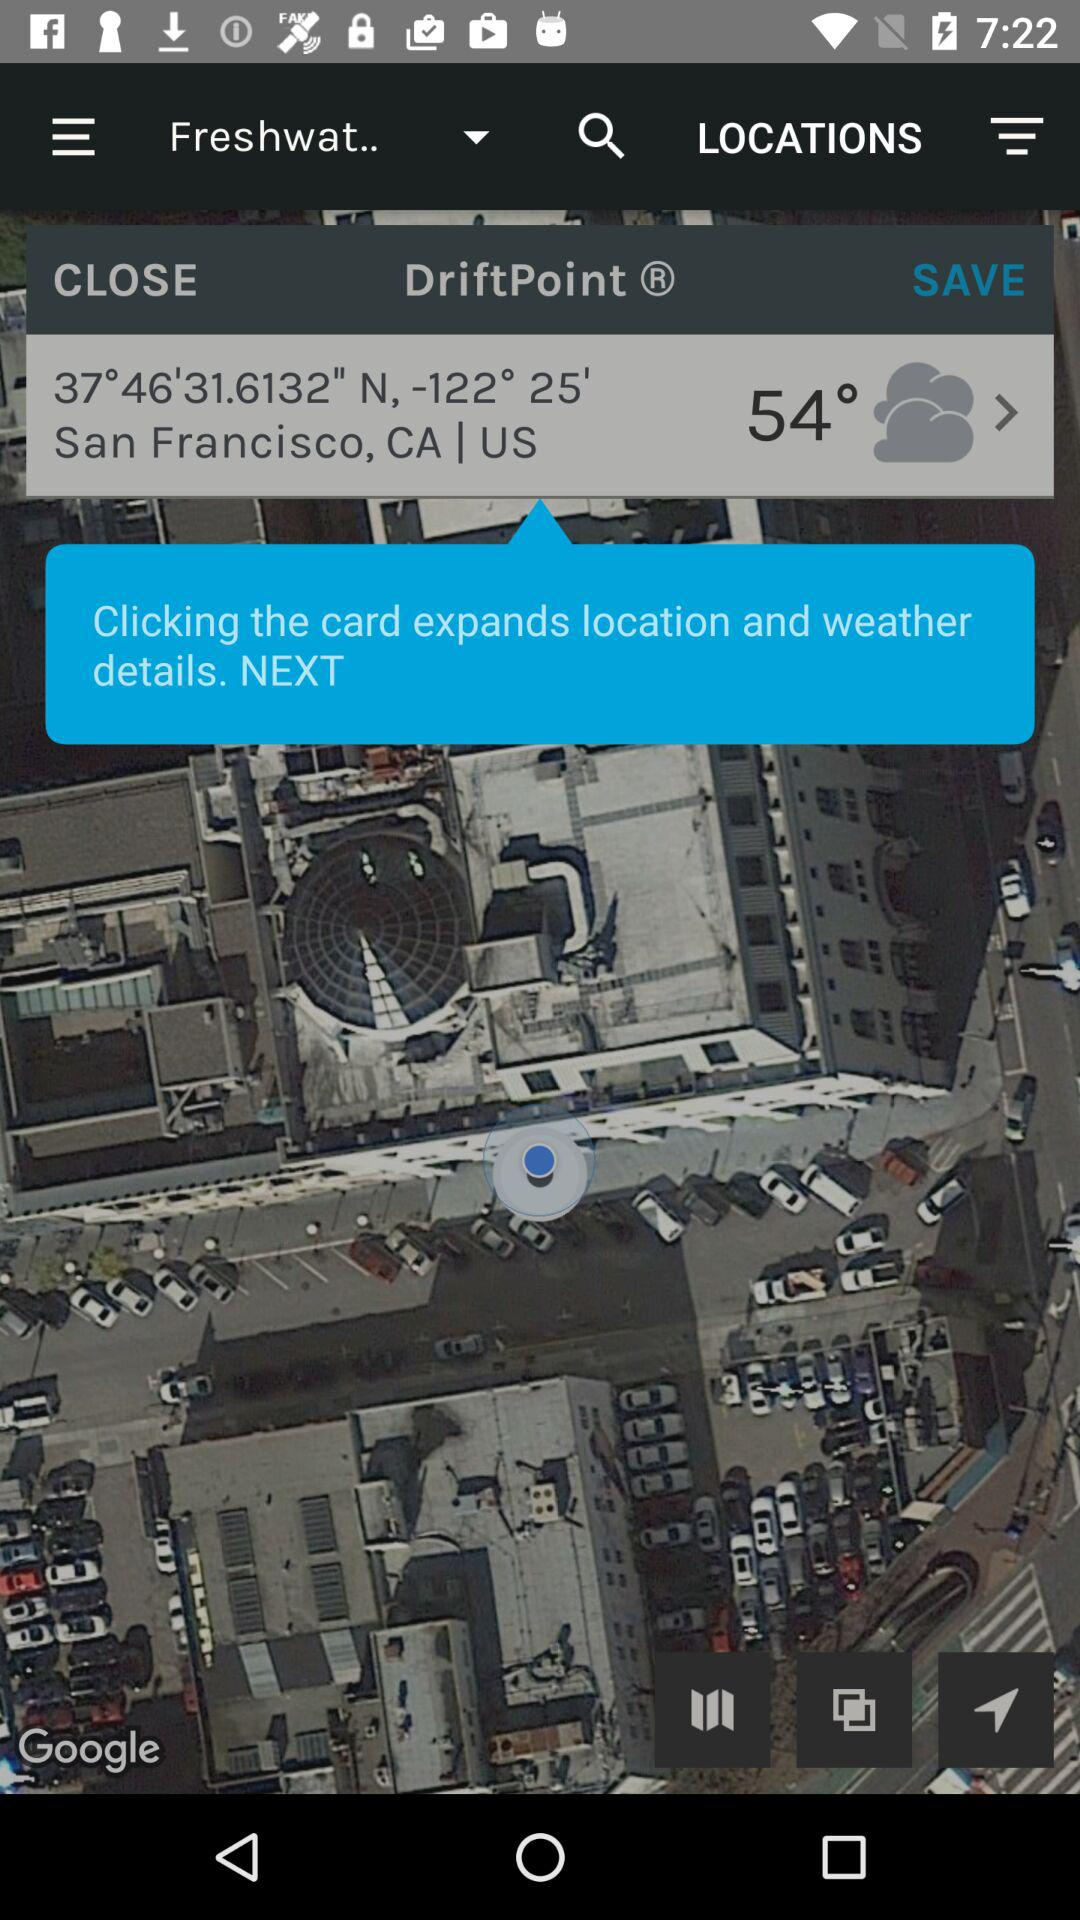What is the location? The location is San Francisco, CA, US. 